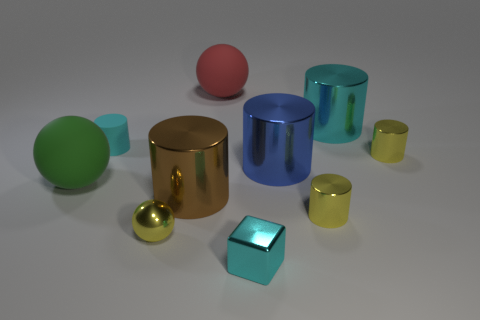What number of red objects are the same size as the red rubber sphere?
Give a very brief answer. 0. There is a large sphere that is on the right side of the small yellow ball; what is its color?
Your response must be concise. Red. What number of other things are the same size as the shiny sphere?
Your response must be concise. 4. What size is the sphere that is both in front of the big blue shiny thing and behind the big brown metallic cylinder?
Provide a short and direct response. Large. There is a tiny ball; does it have the same color as the matte ball left of the brown metallic cylinder?
Provide a succinct answer. No. Is there a large red matte object that has the same shape as the tiny matte thing?
Provide a short and direct response. No. What number of objects are brown cylinders or yellow cylinders that are on the right side of the tiny rubber object?
Provide a short and direct response. 3. How many other things are the same material as the yellow sphere?
Make the answer very short. 6. What number of objects are either big brown cylinders or large blue metallic cylinders?
Keep it short and to the point. 2. Is the number of cyan metallic cubes behind the cyan shiny cylinder greater than the number of big brown metal cylinders that are in front of the large brown cylinder?
Offer a terse response. No. 